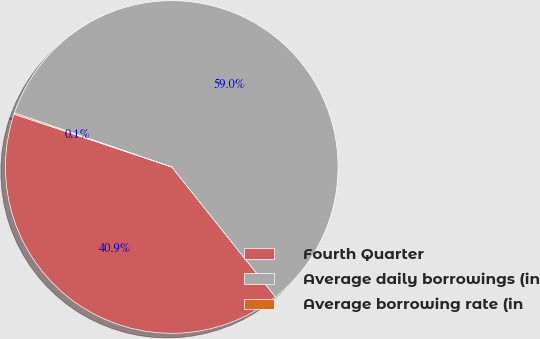<chart> <loc_0><loc_0><loc_500><loc_500><pie_chart><fcel>Fourth Quarter<fcel>Average daily borrowings (in<fcel>Average borrowing rate (in<nl><fcel>40.86%<fcel>59.02%<fcel>0.12%<nl></chart> 